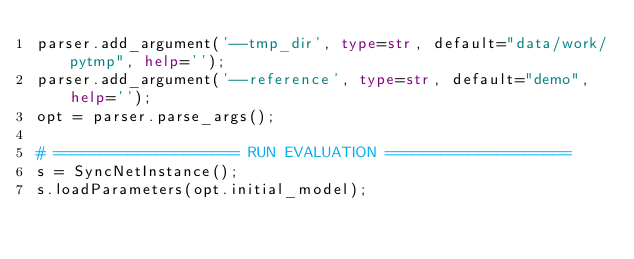<code> <loc_0><loc_0><loc_500><loc_500><_Python_>parser.add_argument('--tmp_dir', type=str, default="data/work/pytmp", help='');
parser.add_argument('--reference', type=str, default="demo", help='');
opt = parser.parse_args();

# ==================== RUN EVALUATION ====================
s = SyncNetInstance();
s.loadParameters(opt.initial_model);</code> 